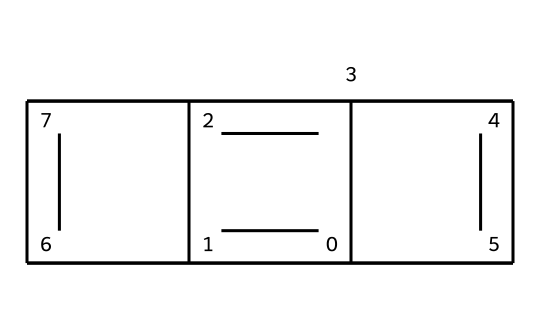What is the main type of bonding present in this chemical structure? The chemical structure primarily consists of carbon atoms arranged in a layered hexagonal lattice, which indicates strong covalent bonding between carbon atoms.
Answer: covalent How many carbon atoms are present in the structure? By analyzing the SMILES representation, we can count that there are a total of six carbon atoms represented in the structure.
Answer: six Does the structure have any functional groups? The provided SMILES representation indicates that the structure is made up solely of carbon atoms arranged in a specific manner, without any additional functional groups.
Answer: no What is the primary use of this compound in metalworking? As a dry lubricant, the primary use of graphite is to reduce friction between metal surfaces during machining or assembly processes.
Answer: dry lubricant Why is graphite considered effective as a dry lubricant? Graphite has a layered structure that allows the layers to slide over each other easily, reducing friction and wear between moving metal parts.
Answer: layered structure 